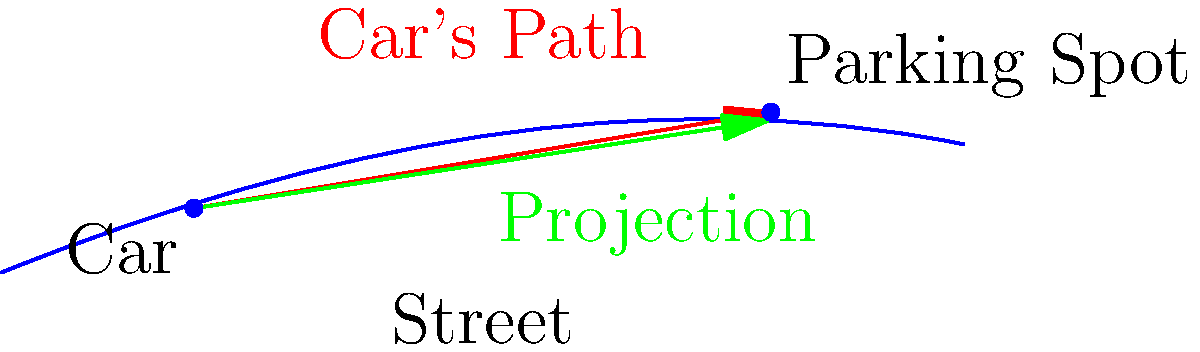A car is attempting to parallel park on a curving street. The car's current position is represented by the vector $\mathbf{a} = (30, 10)$, and the desired parking spot is at $\mathbf{b} = (120, 25)$. The street's curve can be approximated by the vector $\mathbf{s} = (90, 15)$ in the relevant section. Calculate the length of the projection of the car's path onto the street's direction to determine if parallel parking is possible. Assume parallel parking is possible if the projection length is less than 100 units. To solve this problem, we'll follow these steps:

1) First, calculate the vector representing the car's path:
   $\mathbf{v} = \mathbf{b} - \mathbf{a} = (120, 25) - (30, 10) = (90, 15)$

2) The street's direction vector is given as $\mathbf{s} = (90, 15)$

3) To find the projection of $\mathbf{v}$ onto $\mathbf{s}$, we use the formula:
   $\text{proj}_{\mathbf{s}}\mathbf{v} = \frac{\mathbf{v} \cdot \mathbf{s}}{\|\mathbf{s}\|^2} \mathbf{s}$

4) Calculate the dot product $\mathbf{v} \cdot \mathbf{s}$:
   $\mathbf{v} \cdot \mathbf{s} = 90 \cdot 90 + 15 \cdot 15 = 8100 + 225 = 8325$

5) Calculate $\|\mathbf{s}\|^2$:
   $\|\mathbf{s}\|^2 = 90^2 + 15^2 = 8100 + 225 = 8325$

6) Now we can calculate the scalar projection:
   $\frac{\mathbf{v} \cdot \mathbf{s}}{\|\mathbf{s}\|^2} = \frac{8325}{8325} = 1$

7) The projection vector is:
   $\text{proj}_{\mathbf{s}}\mathbf{v} = 1 \cdot (90, 15) = (90, 15)$

8) The length of this projection is:
   $\|\text{proj}_{\mathbf{s}}\mathbf{v}\| = \sqrt{90^2 + 15^2} = \sqrt{8325} \approx 91.24$

9) Since 91.24 < 100, parallel parking is possible.
Answer: Parallel parking is possible (projection length ≈ 91.24 < 100). 